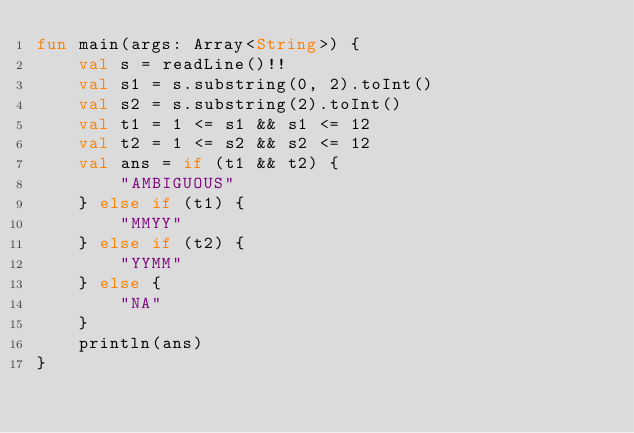<code> <loc_0><loc_0><loc_500><loc_500><_Kotlin_>fun main(args: Array<String>) {
    val s = readLine()!!
    val s1 = s.substring(0, 2).toInt()
    val s2 = s.substring(2).toInt()
    val t1 = 1 <= s1 && s1 <= 12
    val t2 = 1 <= s2 && s2 <= 12
    val ans = if (t1 && t2) {
        "AMBIGUOUS"
    } else if (t1) {
        "MMYY"
    } else if (t2) {
        "YYMM"
    } else {
        "NA"
    }
    println(ans)
}
</code> 